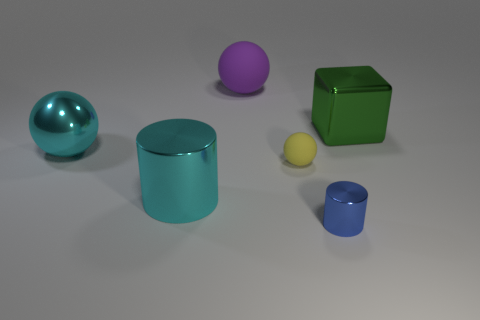Subtract all large balls. How many balls are left? 1 Add 3 purple matte objects. How many objects exist? 9 Subtract all purple balls. How many balls are left? 2 Subtract 2 balls. How many balls are left? 1 Subtract all blocks. How many objects are left? 5 Subtract 1 green cubes. How many objects are left? 5 Subtract all gray spheres. Subtract all cyan cubes. How many spheres are left? 3 Subtract all tiny green cylinders. Subtract all large balls. How many objects are left? 4 Add 3 large metallic objects. How many large metallic objects are left? 6 Add 6 purple spheres. How many purple spheres exist? 7 